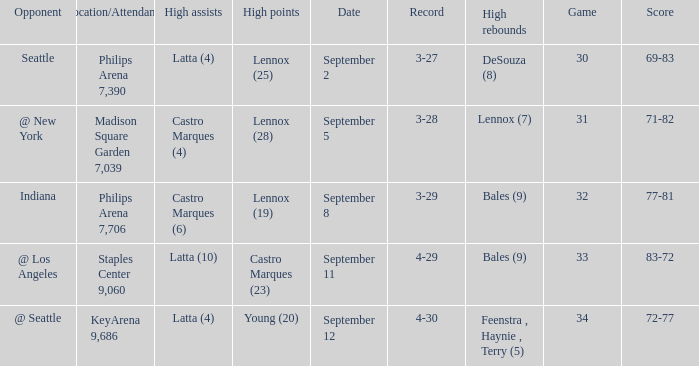Which Location/Attendance has High rebounds of lennox (7)? Madison Square Garden 7,039. 